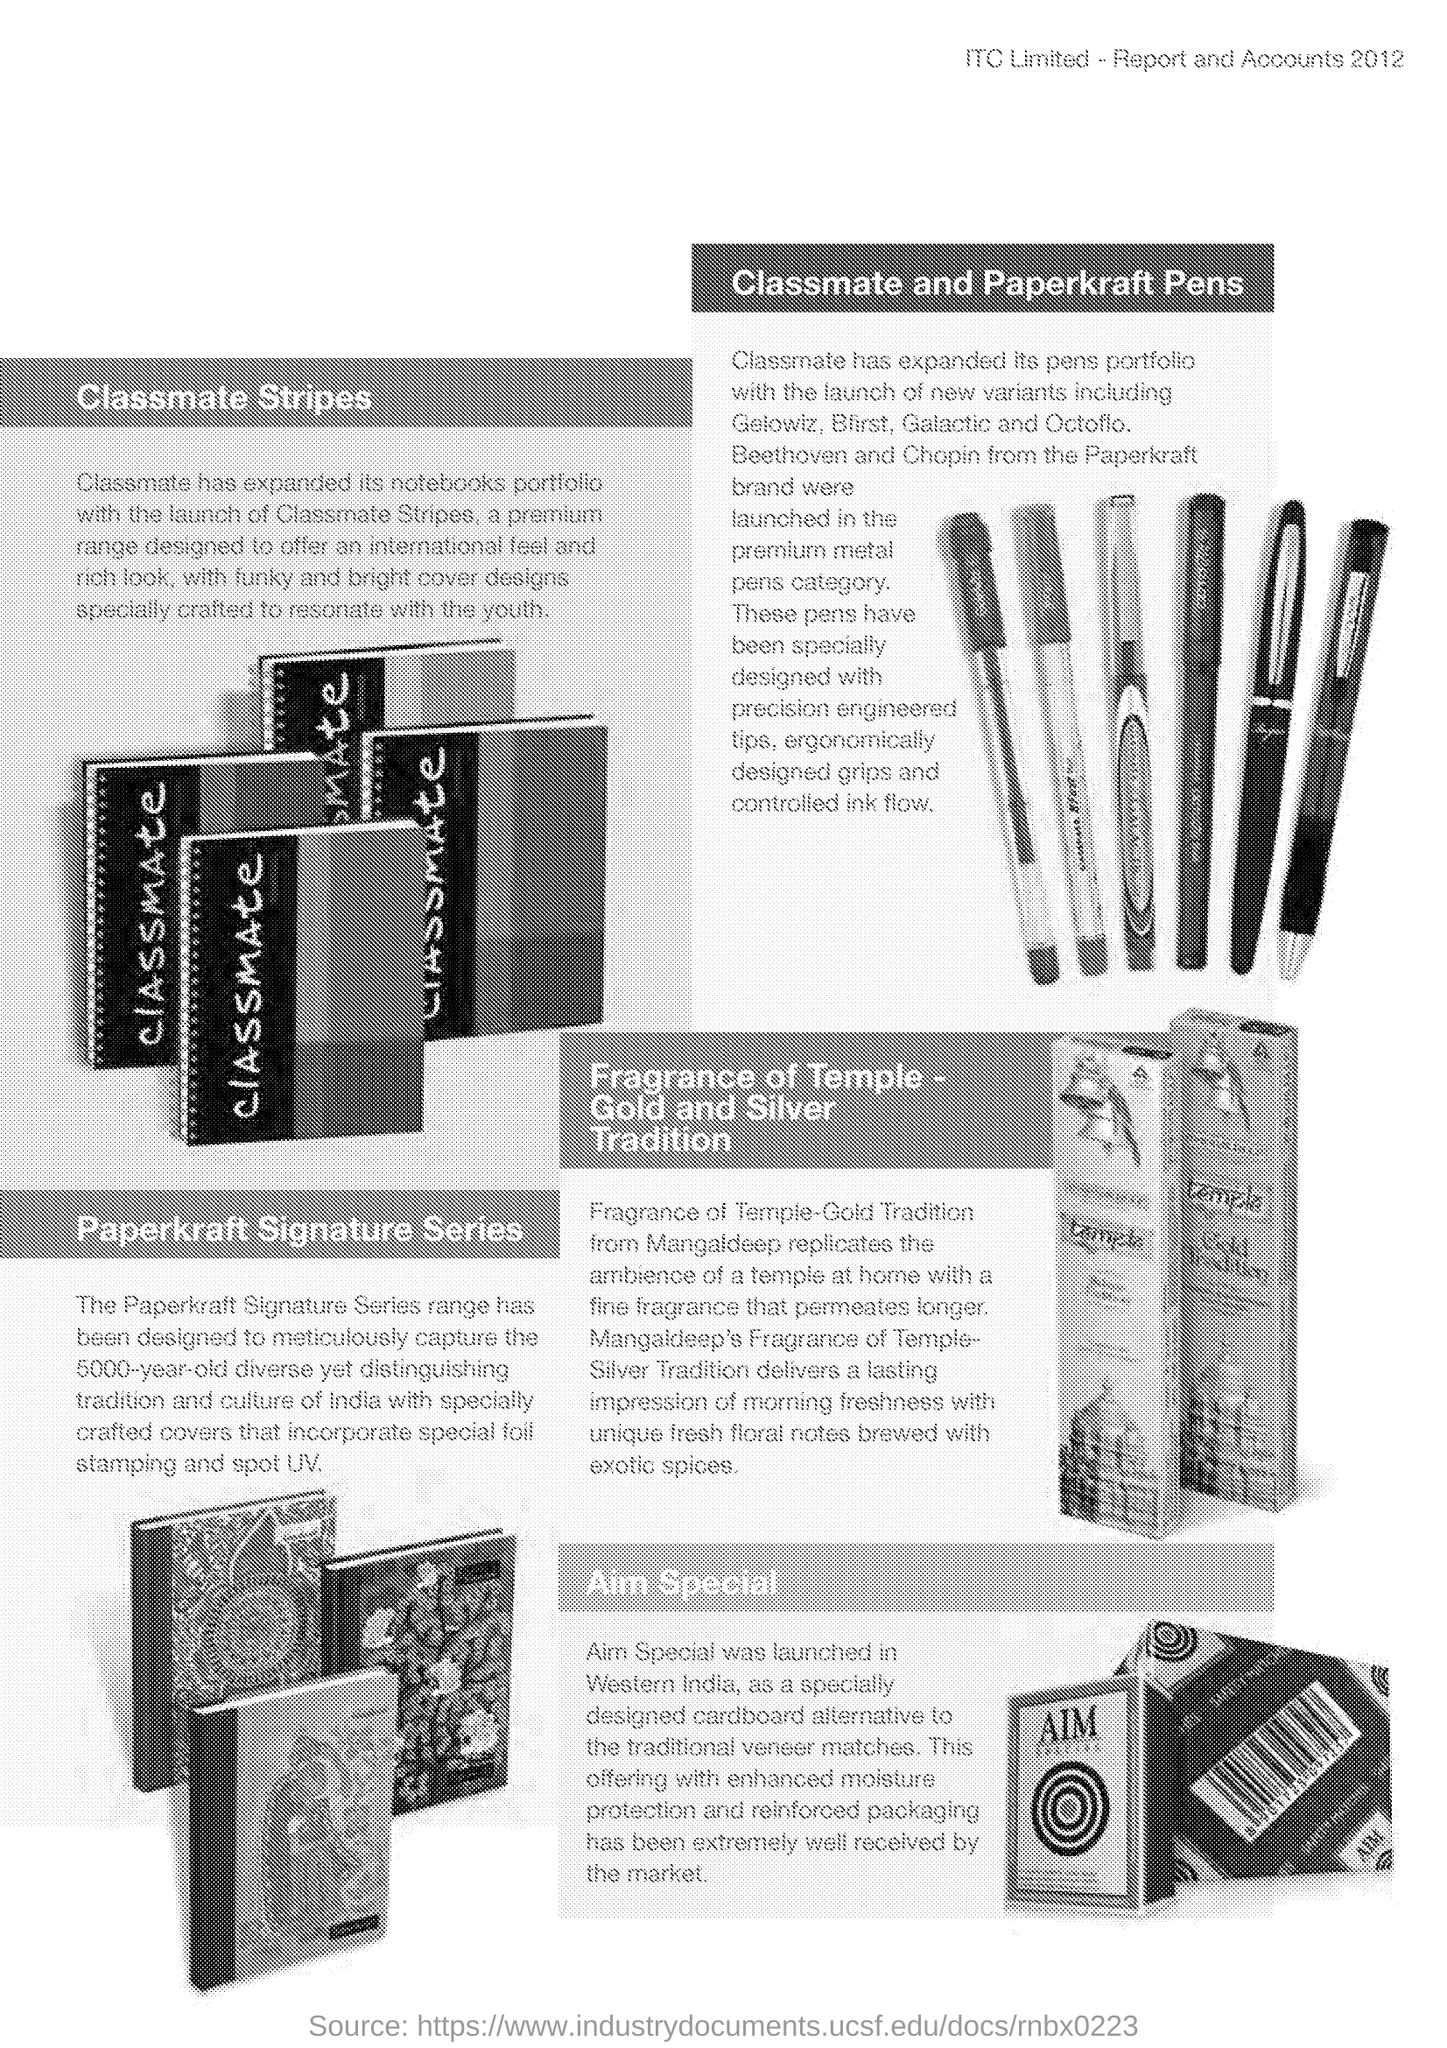Draw attention to some important aspects in this diagram. Aim Special was launched in Western India. 